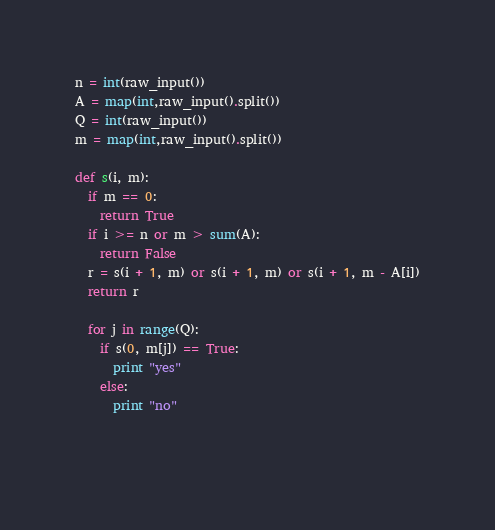<code> <loc_0><loc_0><loc_500><loc_500><_Python_>n = int(raw_input())
A = map(int,raw_input().split())
Q = int(raw_input())
m = map(int,raw_input().split())

def s(i, m):
  if m == 0:
    return True
  if i >= n or m > sum(A):
    return False
  r = s(i + 1, m) or s(i + 1, m) or s(i + 1, m - A[i])
  return r

  for j in range(Q):
    if s(0, m[j]) == True:
      print "yes"
    else:
      print "no"
  
  </code> 